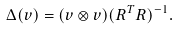<formula> <loc_0><loc_0><loc_500><loc_500>\Delta ( v ) = ( v \otimes v ) ( R ^ { T } R ) ^ { - 1 } .</formula> 